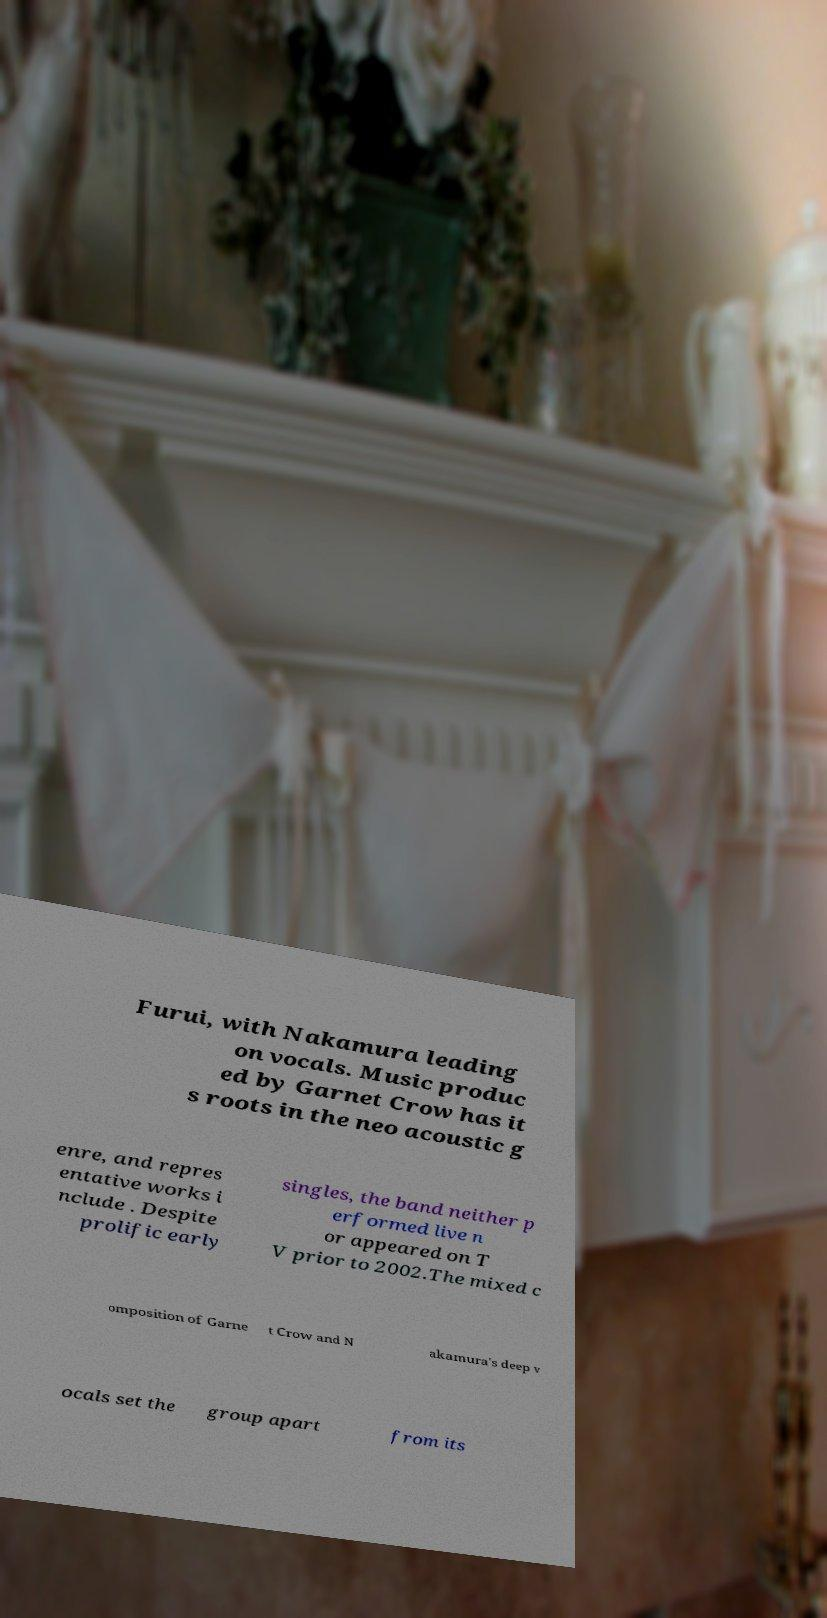Please read and relay the text visible in this image. What does it say? Furui, with Nakamura leading on vocals. Music produc ed by Garnet Crow has it s roots in the neo acoustic g enre, and repres entative works i nclude . Despite prolific early singles, the band neither p erformed live n or appeared on T V prior to 2002.The mixed c omposition of Garne t Crow and N akamura's deep v ocals set the group apart from its 